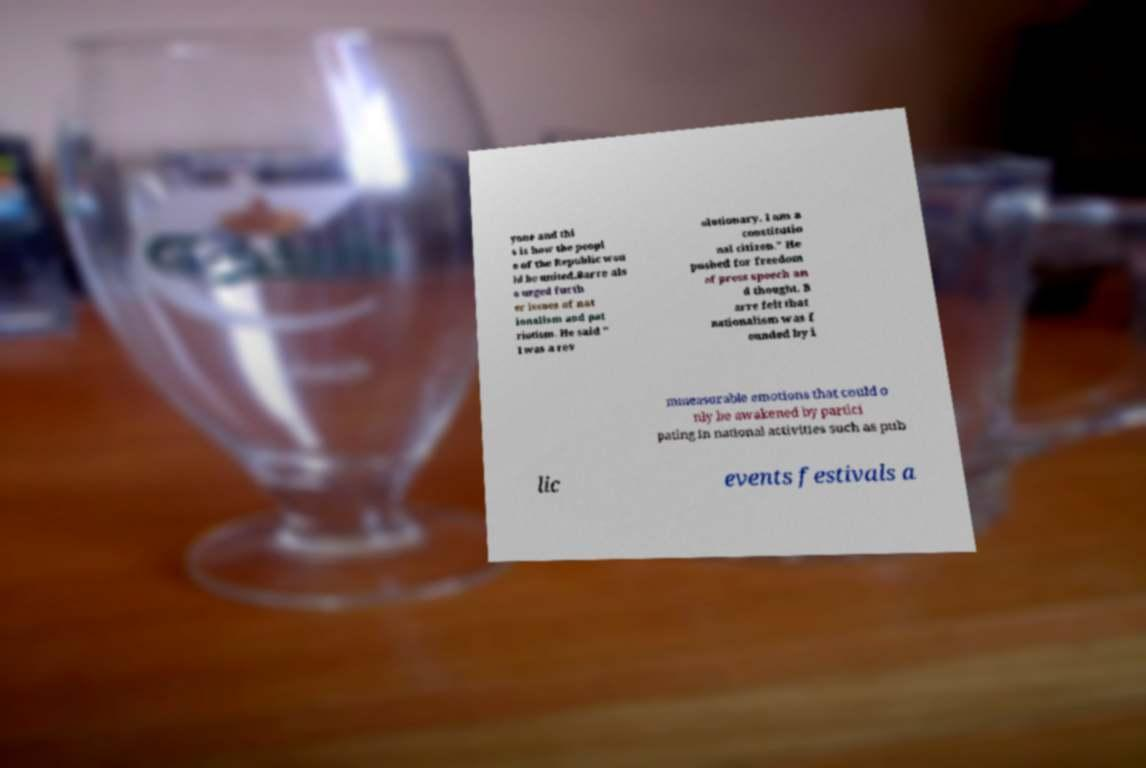Please identify and transcribe the text found in this image. yone and thi s is how the peopl e of the Republic wou ld be united.Barre als o urged furth er issues of nat ionalism and pat riotism. He said " I was a rev olutionary. I am a constitutio nal citizen." He pushed for freedom of press speech an d thought. B arre felt that nationalism was f ounded by i mmeasurable emotions that could o nly be awakened by partici pating in national activities such as pub lic events festivals a 